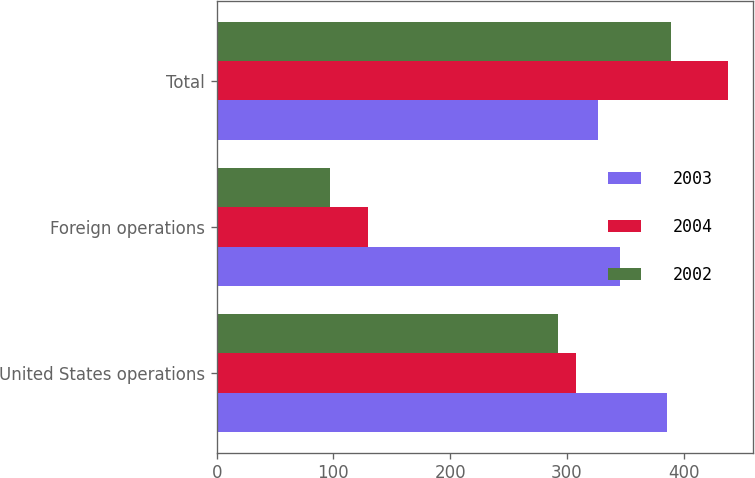Convert chart to OTSL. <chart><loc_0><loc_0><loc_500><loc_500><stacked_bar_chart><ecel><fcel>United States operations<fcel>Foreign operations<fcel>Total<nl><fcel>2003<fcel>385.7<fcel>345.8<fcel>326.7<nl><fcel>2004<fcel>307.6<fcel>129.9<fcel>437.5<nl><fcel>2002<fcel>292<fcel>96.9<fcel>388.9<nl></chart> 